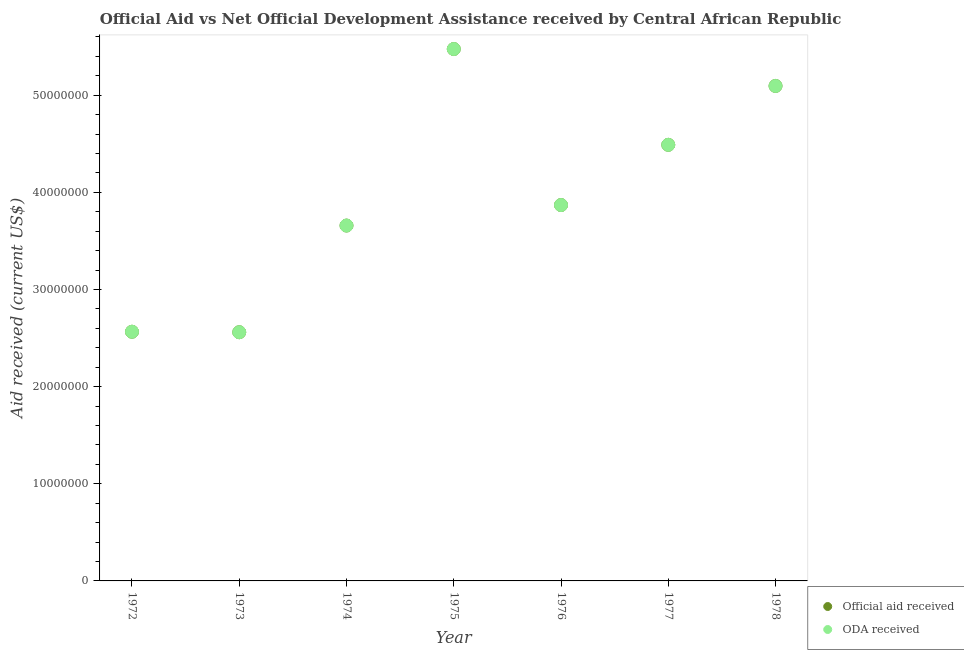How many different coloured dotlines are there?
Offer a terse response. 2. Is the number of dotlines equal to the number of legend labels?
Your answer should be compact. Yes. What is the oda received in 1974?
Offer a terse response. 3.66e+07. Across all years, what is the maximum oda received?
Provide a short and direct response. 5.48e+07. Across all years, what is the minimum oda received?
Give a very brief answer. 2.56e+07. In which year was the official aid received maximum?
Your response must be concise. 1975. In which year was the official aid received minimum?
Your answer should be compact. 1973. What is the total official aid received in the graph?
Your response must be concise. 2.77e+08. What is the difference between the oda received in 1975 and that in 1976?
Offer a terse response. 1.61e+07. What is the difference between the official aid received in 1977 and the oda received in 1973?
Keep it short and to the point. 1.93e+07. What is the average oda received per year?
Your answer should be compact. 3.96e+07. In how many years, is the official aid received greater than 52000000 US$?
Provide a short and direct response. 1. What is the ratio of the oda received in 1973 to that in 1974?
Offer a very short reply. 0.7. Is the oda received in 1973 less than that in 1978?
Give a very brief answer. Yes. What is the difference between the highest and the second highest official aid received?
Keep it short and to the point. 3.80e+06. What is the difference between the highest and the lowest oda received?
Your response must be concise. 2.92e+07. Is the oda received strictly greater than the official aid received over the years?
Make the answer very short. No. Is the official aid received strictly less than the oda received over the years?
Your response must be concise. No. How many dotlines are there?
Provide a succinct answer. 2. What is the difference between two consecutive major ticks on the Y-axis?
Provide a succinct answer. 1.00e+07. Does the graph contain any zero values?
Make the answer very short. No. Does the graph contain grids?
Your response must be concise. No. What is the title of the graph?
Ensure brevity in your answer.  Official Aid vs Net Official Development Assistance received by Central African Republic . What is the label or title of the X-axis?
Your answer should be very brief. Year. What is the label or title of the Y-axis?
Ensure brevity in your answer.  Aid received (current US$). What is the Aid received (current US$) in Official aid received in 1972?
Your answer should be very brief. 2.56e+07. What is the Aid received (current US$) of ODA received in 1972?
Make the answer very short. 2.56e+07. What is the Aid received (current US$) of Official aid received in 1973?
Keep it short and to the point. 2.56e+07. What is the Aid received (current US$) in ODA received in 1973?
Provide a succinct answer. 2.56e+07. What is the Aid received (current US$) in Official aid received in 1974?
Ensure brevity in your answer.  3.66e+07. What is the Aid received (current US$) in ODA received in 1974?
Give a very brief answer. 3.66e+07. What is the Aid received (current US$) of Official aid received in 1975?
Keep it short and to the point. 5.48e+07. What is the Aid received (current US$) of ODA received in 1975?
Offer a very short reply. 5.48e+07. What is the Aid received (current US$) of Official aid received in 1976?
Make the answer very short. 3.87e+07. What is the Aid received (current US$) of ODA received in 1976?
Offer a very short reply. 3.87e+07. What is the Aid received (current US$) of Official aid received in 1977?
Ensure brevity in your answer.  4.49e+07. What is the Aid received (current US$) of ODA received in 1977?
Provide a succinct answer. 4.49e+07. What is the Aid received (current US$) in Official aid received in 1978?
Provide a short and direct response. 5.10e+07. What is the Aid received (current US$) of ODA received in 1978?
Offer a very short reply. 5.10e+07. Across all years, what is the maximum Aid received (current US$) of Official aid received?
Offer a very short reply. 5.48e+07. Across all years, what is the maximum Aid received (current US$) in ODA received?
Ensure brevity in your answer.  5.48e+07. Across all years, what is the minimum Aid received (current US$) of Official aid received?
Make the answer very short. 2.56e+07. Across all years, what is the minimum Aid received (current US$) of ODA received?
Offer a very short reply. 2.56e+07. What is the total Aid received (current US$) in Official aid received in the graph?
Your response must be concise. 2.77e+08. What is the total Aid received (current US$) of ODA received in the graph?
Offer a very short reply. 2.77e+08. What is the difference between the Aid received (current US$) in Official aid received in 1972 and that in 1973?
Give a very brief answer. 5.00e+04. What is the difference between the Aid received (current US$) in ODA received in 1972 and that in 1973?
Offer a very short reply. 5.00e+04. What is the difference between the Aid received (current US$) of Official aid received in 1972 and that in 1974?
Your response must be concise. -1.09e+07. What is the difference between the Aid received (current US$) of ODA received in 1972 and that in 1974?
Your answer should be compact. -1.09e+07. What is the difference between the Aid received (current US$) of Official aid received in 1972 and that in 1975?
Offer a terse response. -2.91e+07. What is the difference between the Aid received (current US$) of ODA received in 1972 and that in 1975?
Your answer should be very brief. -2.91e+07. What is the difference between the Aid received (current US$) in Official aid received in 1972 and that in 1976?
Provide a short and direct response. -1.30e+07. What is the difference between the Aid received (current US$) in ODA received in 1972 and that in 1976?
Your answer should be very brief. -1.30e+07. What is the difference between the Aid received (current US$) of Official aid received in 1972 and that in 1977?
Your response must be concise. -1.92e+07. What is the difference between the Aid received (current US$) of ODA received in 1972 and that in 1977?
Your answer should be very brief. -1.92e+07. What is the difference between the Aid received (current US$) of Official aid received in 1972 and that in 1978?
Offer a very short reply. -2.53e+07. What is the difference between the Aid received (current US$) of ODA received in 1972 and that in 1978?
Your response must be concise. -2.53e+07. What is the difference between the Aid received (current US$) in Official aid received in 1973 and that in 1974?
Keep it short and to the point. -1.10e+07. What is the difference between the Aid received (current US$) of ODA received in 1973 and that in 1974?
Provide a short and direct response. -1.10e+07. What is the difference between the Aid received (current US$) in Official aid received in 1973 and that in 1975?
Ensure brevity in your answer.  -2.92e+07. What is the difference between the Aid received (current US$) in ODA received in 1973 and that in 1975?
Offer a very short reply. -2.92e+07. What is the difference between the Aid received (current US$) in Official aid received in 1973 and that in 1976?
Provide a short and direct response. -1.31e+07. What is the difference between the Aid received (current US$) in ODA received in 1973 and that in 1976?
Provide a succinct answer. -1.31e+07. What is the difference between the Aid received (current US$) in Official aid received in 1973 and that in 1977?
Offer a very short reply. -1.93e+07. What is the difference between the Aid received (current US$) in ODA received in 1973 and that in 1977?
Provide a short and direct response. -1.93e+07. What is the difference between the Aid received (current US$) of Official aid received in 1973 and that in 1978?
Ensure brevity in your answer.  -2.54e+07. What is the difference between the Aid received (current US$) of ODA received in 1973 and that in 1978?
Your answer should be very brief. -2.54e+07. What is the difference between the Aid received (current US$) of Official aid received in 1974 and that in 1975?
Provide a succinct answer. -1.82e+07. What is the difference between the Aid received (current US$) of ODA received in 1974 and that in 1975?
Offer a very short reply. -1.82e+07. What is the difference between the Aid received (current US$) in Official aid received in 1974 and that in 1976?
Offer a terse response. -2.11e+06. What is the difference between the Aid received (current US$) of ODA received in 1974 and that in 1976?
Make the answer very short. -2.11e+06. What is the difference between the Aid received (current US$) in Official aid received in 1974 and that in 1977?
Make the answer very short. -8.31e+06. What is the difference between the Aid received (current US$) in ODA received in 1974 and that in 1977?
Offer a very short reply. -8.31e+06. What is the difference between the Aid received (current US$) of Official aid received in 1974 and that in 1978?
Offer a very short reply. -1.44e+07. What is the difference between the Aid received (current US$) in ODA received in 1974 and that in 1978?
Ensure brevity in your answer.  -1.44e+07. What is the difference between the Aid received (current US$) of Official aid received in 1975 and that in 1976?
Give a very brief answer. 1.61e+07. What is the difference between the Aid received (current US$) in ODA received in 1975 and that in 1976?
Keep it short and to the point. 1.61e+07. What is the difference between the Aid received (current US$) of Official aid received in 1975 and that in 1977?
Make the answer very short. 9.86e+06. What is the difference between the Aid received (current US$) in ODA received in 1975 and that in 1977?
Your answer should be compact. 9.86e+06. What is the difference between the Aid received (current US$) of Official aid received in 1975 and that in 1978?
Ensure brevity in your answer.  3.80e+06. What is the difference between the Aid received (current US$) in ODA received in 1975 and that in 1978?
Provide a succinct answer. 3.80e+06. What is the difference between the Aid received (current US$) in Official aid received in 1976 and that in 1977?
Provide a short and direct response. -6.20e+06. What is the difference between the Aid received (current US$) of ODA received in 1976 and that in 1977?
Provide a short and direct response. -6.20e+06. What is the difference between the Aid received (current US$) of Official aid received in 1976 and that in 1978?
Offer a terse response. -1.23e+07. What is the difference between the Aid received (current US$) in ODA received in 1976 and that in 1978?
Your answer should be compact. -1.23e+07. What is the difference between the Aid received (current US$) in Official aid received in 1977 and that in 1978?
Offer a very short reply. -6.06e+06. What is the difference between the Aid received (current US$) in ODA received in 1977 and that in 1978?
Keep it short and to the point. -6.06e+06. What is the difference between the Aid received (current US$) of Official aid received in 1972 and the Aid received (current US$) of ODA received in 1974?
Keep it short and to the point. -1.09e+07. What is the difference between the Aid received (current US$) of Official aid received in 1972 and the Aid received (current US$) of ODA received in 1975?
Provide a succinct answer. -2.91e+07. What is the difference between the Aid received (current US$) in Official aid received in 1972 and the Aid received (current US$) in ODA received in 1976?
Offer a terse response. -1.30e+07. What is the difference between the Aid received (current US$) in Official aid received in 1972 and the Aid received (current US$) in ODA received in 1977?
Your response must be concise. -1.92e+07. What is the difference between the Aid received (current US$) in Official aid received in 1972 and the Aid received (current US$) in ODA received in 1978?
Provide a short and direct response. -2.53e+07. What is the difference between the Aid received (current US$) of Official aid received in 1973 and the Aid received (current US$) of ODA received in 1974?
Make the answer very short. -1.10e+07. What is the difference between the Aid received (current US$) in Official aid received in 1973 and the Aid received (current US$) in ODA received in 1975?
Your response must be concise. -2.92e+07. What is the difference between the Aid received (current US$) in Official aid received in 1973 and the Aid received (current US$) in ODA received in 1976?
Offer a very short reply. -1.31e+07. What is the difference between the Aid received (current US$) of Official aid received in 1973 and the Aid received (current US$) of ODA received in 1977?
Keep it short and to the point. -1.93e+07. What is the difference between the Aid received (current US$) in Official aid received in 1973 and the Aid received (current US$) in ODA received in 1978?
Offer a very short reply. -2.54e+07. What is the difference between the Aid received (current US$) of Official aid received in 1974 and the Aid received (current US$) of ODA received in 1975?
Your response must be concise. -1.82e+07. What is the difference between the Aid received (current US$) of Official aid received in 1974 and the Aid received (current US$) of ODA received in 1976?
Give a very brief answer. -2.11e+06. What is the difference between the Aid received (current US$) in Official aid received in 1974 and the Aid received (current US$) in ODA received in 1977?
Ensure brevity in your answer.  -8.31e+06. What is the difference between the Aid received (current US$) in Official aid received in 1974 and the Aid received (current US$) in ODA received in 1978?
Provide a succinct answer. -1.44e+07. What is the difference between the Aid received (current US$) in Official aid received in 1975 and the Aid received (current US$) in ODA received in 1976?
Your answer should be very brief. 1.61e+07. What is the difference between the Aid received (current US$) of Official aid received in 1975 and the Aid received (current US$) of ODA received in 1977?
Provide a succinct answer. 9.86e+06. What is the difference between the Aid received (current US$) of Official aid received in 1975 and the Aid received (current US$) of ODA received in 1978?
Give a very brief answer. 3.80e+06. What is the difference between the Aid received (current US$) of Official aid received in 1976 and the Aid received (current US$) of ODA received in 1977?
Offer a terse response. -6.20e+06. What is the difference between the Aid received (current US$) of Official aid received in 1976 and the Aid received (current US$) of ODA received in 1978?
Offer a terse response. -1.23e+07. What is the difference between the Aid received (current US$) of Official aid received in 1977 and the Aid received (current US$) of ODA received in 1978?
Give a very brief answer. -6.06e+06. What is the average Aid received (current US$) in Official aid received per year?
Provide a short and direct response. 3.96e+07. What is the average Aid received (current US$) in ODA received per year?
Provide a succinct answer. 3.96e+07. In the year 1977, what is the difference between the Aid received (current US$) of Official aid received and Aid received (current US$) of ODA received?
Your answer should be compact. 0. In the year 1978, what is the difference between the Aid received (current US$) of Official aid received and Aid received (current US$) of ODA received?
Your answer should be very brief. 0. What is the ratio of the Aid received (current US$) in ODA received in 1972 to that in 1973?
Offer a very short reply. 1. What is the ratio of the Aid received (current US$) in Official aid received in 1972 to that in 1974?
Your response must be concise. 0.7. What is the ratio of the Aid received (current US$) in ODA received in 1972 to that in 1974?
Your response must be concise. 0.7. What is the ratio of the Aid received (current US$) of Official aid received in 1972 to that in 1975?
Offer a very short reply. 0.47. What is the ratio of the Aid received (current US$) of ODA received in 1972 to that in 1975?
Your answer should be compact. 0.47. What is the ratio of the Aid received (current US$) in Official aid received in 1972 to that in 1976?
Offer a terse response. 0.66. What is the ratio of the Aid received (current US$) in ODA received in 1972 to that in 1976?
Offer a terse response. 0.66. What is the ratio of the Aid received (current US$) of Official aid received in 1972 to that in 1977?
Offer a very short reply. 0.57. What is the ratio of the Aid received (current US$) of ODA received in 1972 to that in 1977?
Give a very brief answer. 0.57. What is the ratio of the Aid received (current US$) of Official aid received in 1972 to that in 1978?
Your answer should be very brief. 0.5. What is the ratio of the Aid received (current US$) in ODA received in 1972 to that in 1978?
Keep it short and to the point. 0.5. What is the ratio of the Aid received (current US$) of Official aid received in 1973 to that in 1974?
Keep it short and to the point. 0.7. What is the ratio of the Aid received (current US$) of ODA received in 1973 to that in 1974?
Your response must be concise. 0.7. What is the ratio of the Aid received (current US$) of Official aid received in 1973 to that in 1975?
Keep it short and to the point. 0.47. What is the ratio of the Aid received (current US$) of ODA received in 1973 to that in 1975?
Your response must be concise. 0.47. What is the ratio of the Aid received (current US$) of Official aid received in 1973 to that in 1976?
Offer a terse response. 0.66. What is the ratio of the Aid received (current US$) of ODA received in 1973 to that in 1976?
Your response must be concise. 0.66. What is the ratio of the Aid received (current US$) in Official aid received in 1973 to that in 1977?
Your response must be concise. 0.57. What is the ratio of the Aid received (current US$) of ODA received in 1973 to that in 1977?
Your response must be concise. 0.57. What is the ratio of the Aid received (current US$) in Official aid received in 1973 to that in 1978?
Make the answer very short. 0.5. What is the ratio of the Aid received (current US$) of ODA received in 1973 to that in 1978?
Provide a succinct answer. 0.5. What is the ratio of the Aid received (current US$) in Official aid received in 1974 to that in 1975?
Offer a terse response. 0.67. What is the ratio of the Aid received (current US$) of ODA received in 1974 to that in 1975?
Provide a succinct answer. 0.67. What is the ratio of the Aid received (current US$) in Official aid received in 1974 to that in 1976?
Provide a succinct answer. 0.95. What is the ratio of the Aid received (current US$) in ODA received in 1974 to that in 1976?
Give a very brief answer. 0.95. What is the ratio of the Aid received (current US$) of Official aid received in 1974 to that in 1977?
Provide a succinct answer. 0.81. What is the ratio of the Aid received (current US$) in ODA received in 1974 to that in 1977?
Offer a terse response. 0.81. What is the ratio of the Aid received (current US$) in Official aid received in 1974 to that in 1978?
Offer a terse response. 0.72. What is the ratio of the Aid received (current US$) of ODA received in 1974 to that in 1978?
Offer a very short reply. 0.72. What is the ratio of the Aid received (current US$) in Official aid received in 1975 to that in 1976?
Make the answer very short. 1.42. What is the ratio of the Aid received (current US$) of ODA received in 1975 to that in 1976?
Give a very brief answer. 1.42. What is the ratio of the Aid received (current US$) of Official aid received in 1975 to that in 1977?
Your response must be concise. 1.22. What is the ratio of the Aid received (current US$) in ODA received in 1975 to that in 1977?
Give a very brief answer. 1.22. What is the ratio of the Aid received (current US$) in Official aid received in 1975 to that in 1978?
Provide a short and direct response. 1.07. What is the ratio of the Aid received (current US$) of ODA received in 1975 to that in 1978?
Keep it short and to the point. 1.07. What is the ratio of the Aid received (current US$) in Official aid received in 1976 to that in 1977?
Your response must be concise. 0.86. What is the ratio of the Aid received (current US$) of ODA received in 1976 to that in 1977?
Offer a very short reply. 0.86. What is the ratio of the Aid received (current US$) of Official aid received in 1976 to that in 1978?
Offer a terse response. 0.76. What is the ratio of the Aid received (current US$) in ODA received in 1976 to that in 1978?
Give a very brief answer. 0.76. What is the ratio of the Aid received (current US$) in Official aid received in 1977 to that in 1978?
Make the answer very short. 0.88. What is the ratio of the Aid received (current US$) of ODA received in 1977 to that in 1978?
Your answer should be very brief. 0.88. What is the difference between the highest and the second highest Aid received (current US$) of Official aid received?
Your answer should be very brief. 3.80e+06. What is the difference between the highest and the second highest Aid received (current US$) of ODA received?
Your response must be concise. 3.80e+06. What is the difference between the highest and the lowest Aid received (current US$) of Official aid received?
Provide a short and direct response. 2.92e+07. What is the difference between the highest and the lowest Aid received (current US$) of ODA received?
Offer a terse response. 2.92e+07. 